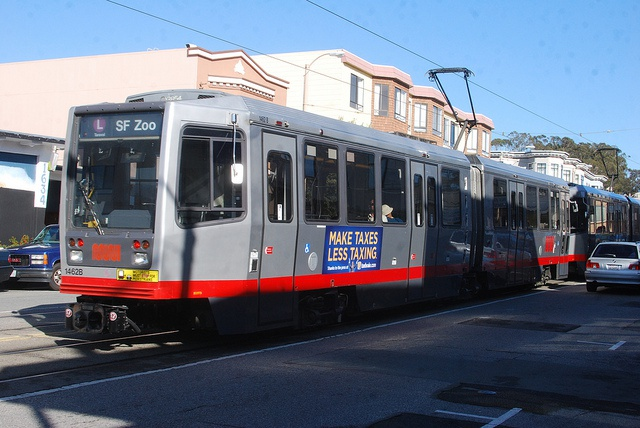Describe the objects in this image and their specific colors. I can see train in lightblue, black, darkgray, gray, and lightgray tones, car in lightblue, black, navy, blue, and darkgray tones, car in lightblue, gray, black, navy, and blue tones, people in lightblue, darkblue, black, blue, and brown tones, and people in lightblue, black, darkgray, and brown tones in this image. 